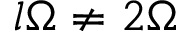<formula> <loc_0><loc_0><loc_500><loc_500>l \Omega \neq 2 \Omega</formula> 